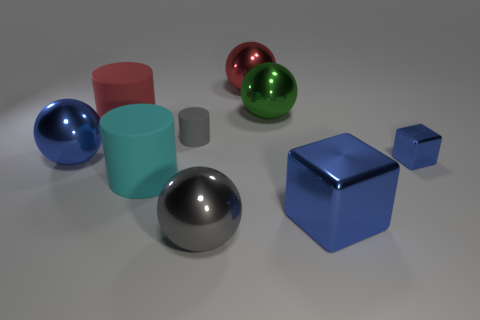How many large metallic cubes are behind the large sphere that is on the left side of the red cylinder?
Your answer should be compact. 0. How many balls are either big green things or blue shiny objects?
Give a very brief answer. 2. There is a large metal object that is in front of the big cyan rubber cylinder and on the left side of the green shiny object; what is its color?
Your response must be concise. Gray. Are there any other things that are the same color as the tiny metallic thing?
Provide a short and direct response. Yes. What is the color of the thing in front of the cube on the left side of the small blue metal object?
Keep it short and to the point. Gray. Is the blue metal ball the same size as the cyan object?
Keep it short and to the point. Yes. Is the material of the tiny thing on the left side of the big green metallic ball the same as the large ball left of the gray rubber cylinder?
Give a very brief answer. No. What is the shape of the gray object in front of the small thing that is right of the green thing behind the gray metal ball?
Your response must be concise. Sphere. Are there more small brown metal cubes than red rubber things?
Offer a very short reply. No. Are there any matte objects?
Ensure brevity in your answer.  Yes. 